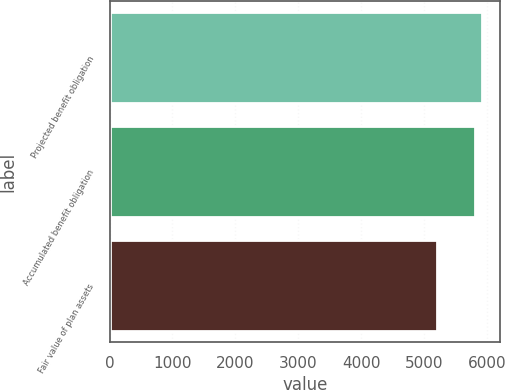Convert chart to OTSL. <chart><loc_0><loc_0><loc_500><loc_500><bar_chart><fcel>Projected benefit obligation<fcel>Accumulated benefit obligation<fcel>Fair value of plan assets<nl><fcel>5920<fcel>5814<fcel>5214<nl></chart> 